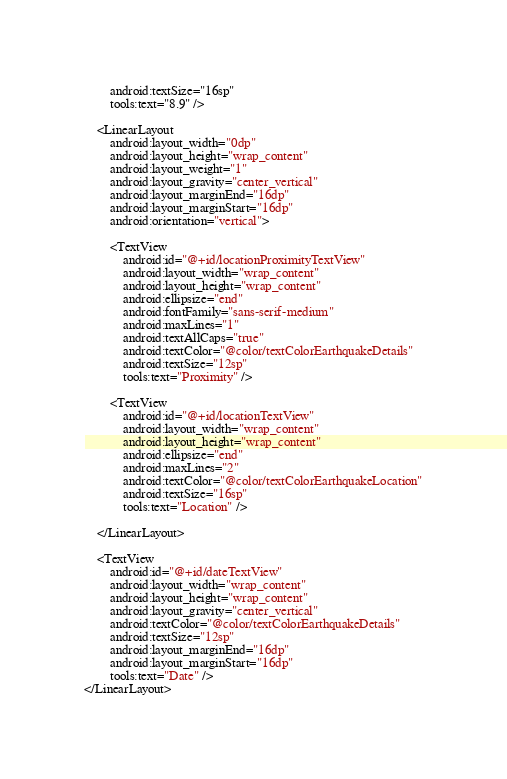Convert code to text. <code><loc_0><loc_0><loc_500><loc_500><_XML_>        android:textSize="16sp"
        tools:text="8.9" />

    <LinearLayout
        android:layout_width="0dp"
        android:layout_height="wrap_content"
        android:layout_weight="1"
        android:layout_gravity="center_vertical"
        android:layout_marginEnd="16dp"
        android:layout_marginStart="16dp"
        android:orientation="vertical">

        <TextView
            android:id="@+id/locationProximityTextView"
            android:layout_width="wrap_content"
            android:layout_height="wrap_content"
            android:ellipsize="end"
            android:fontFamily="sans-serif-medium"
            android:maxLines="1"
            android:textAllCaps="true"
            android:textColor="@color/textColorEarthquakeDetails"
            android:textSize="12sp"
            tools:text="Proximity" />

        <TextView
            android:id="@+id/locationTextView"
            android:layout_width="wrap_content"
            android:layout_height="wrap_content"
            android:ellipsize="end"
            android:maxLines="2"
            android:textColor="@color/textColorEarthquakeLocation"
            android:textSize="16sp"
            tools:text="Location" />

    </LinearLayout>

    <TextView
        android:id="@+id/dateTextView"
        android:layout_width="wrap_content"
        android:layout_height="wrap_content"
        android:layout_gravity="center_vertical"
        android:textColor="@color/textColorEarthquakeDetails"
        android:textSize="12sp"
        android:layout_marginEnd="16dp"
        android:layout_marginStart="16dp"
        tools:text="Date" />
</LinearLayout></code> 